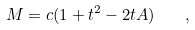Convert formula to latex. <formula><loc_0><loc_0><loc_500><loc_500>M = c ( 1 + t ^ { 2 } - 2 t A ) \quad ,</formula> 